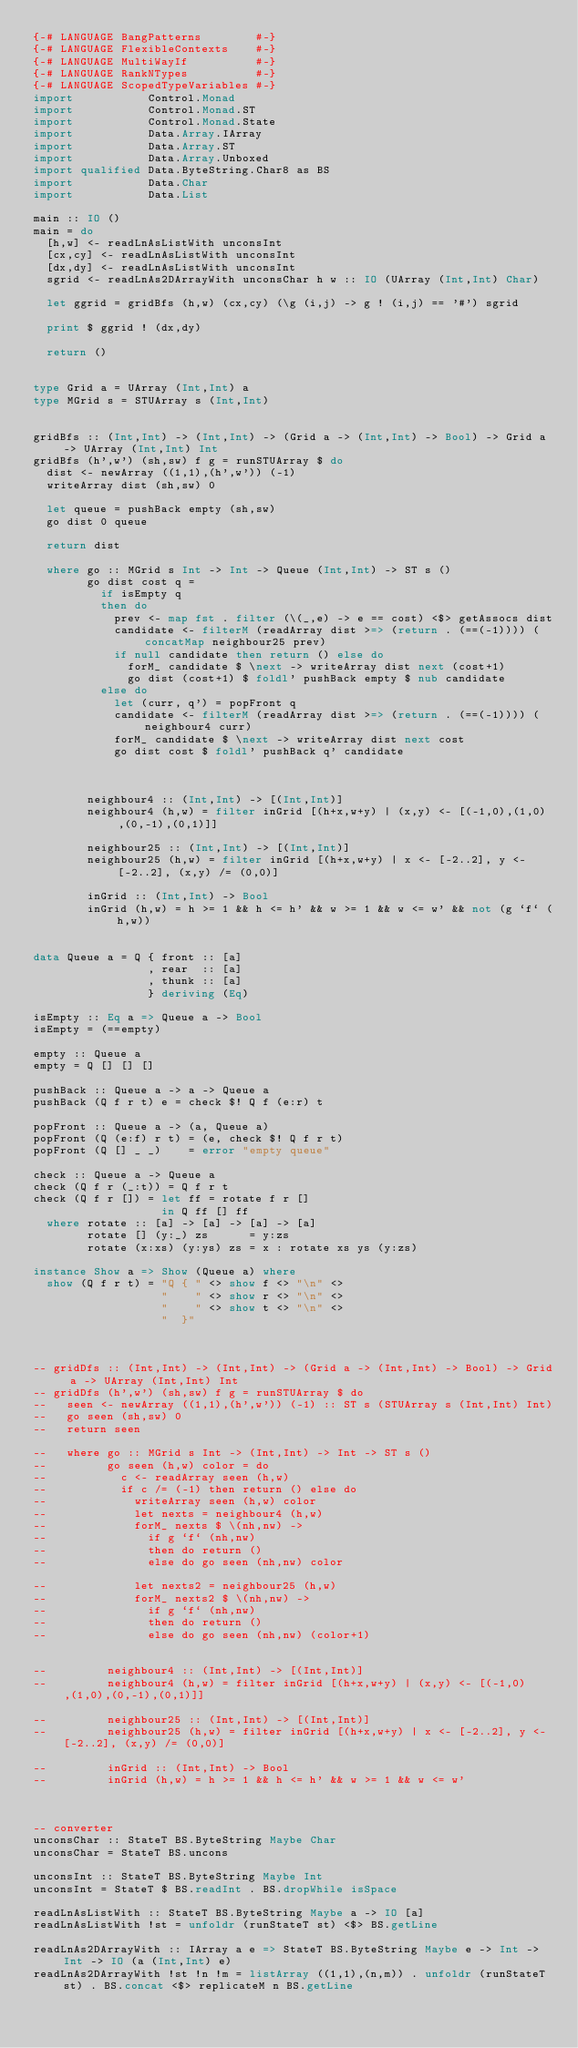<code> <loc_0><loc_0><loc_500><loc_500><_Haskell_>{-# LANGUAGE BangPatterns        #-}
{-# LANGUAGE FlexibleContexts    #-}
{-# LANGUAGE MultiWayIf          #-}
{-# LANGUAGE RankNTypes          #-}
{-# LANGUAGE ScopedTypeVariables #-}
import           Control.Monad
import           Control.Monad.ST
import           Control.Monad.State
import           Data.Array.IArray
import           Data.Array.ST
import           Data.Array.Unboxed
import qualified Data.ByteString.Char8 as BS
import           Data.Char
import           Data.List

main :: IO ()
main = do
  [h,w] <- readLnAsListWith unconsInt
  [cx,cy] <- readLnAsListWith unconsInt
  [dx,dy] <- readLnAsListWith unconsInt
  sgrid <- readLnAs2DArrayWith unconsChar h w :: IO (UArray (Int,Int) Char)

  let ggrid = gridBfs (h,w) (cx,cy) (\g (i,j) -> g ! (i,j) == '#') sgrid

  print $ ggrid ! (dx,dy)

  return ()


type Grid a = UArray (Int,Int) a
type MGrid s = STUArray s (Int,Int)


gridBfs :: (Int,Int) -> (Int,Int) -> (Grid a -> (Int,Int) -> Bool) -> Grid a -> UArray (Int,Int) Int
gridBfs (h',w') (sh,sw) f g = runSTUArray $ do
  dist <- newArray ((1,1),(h',w')) (-1)
  writeArray dist (sh,sw) 0

  let queue = pushBack empty (sh,sw)
  go dist 0 queue

  return dist

  where go :: MGrid s Int -> Int -> Queue (Int,Int) -> ST s ()
        go dist cost q =
          if isEmpty q
          then do
            prev <- map fst . filter (\(_,e) -> e == cost) <$> getAssocs dist
            candidate <- filterM (readArray dist >=> (return . (==(-1)))) (concatMap neighbour25 prev)
            if null candidate then return () else do
              forM_ candidate $ \next -> writeArray dist next (cost+1)
              go dist (cost+1) $ foldl' pushBack empty $ nub candidate
          else do
            let (curr, q') = popFront q
            candidate <- filterM (readArray dist >=> (return . (==(-1)))) (neighbour4 curr)
            forM_ candidate $ \next -> writeArray dist next cost
            go dist cost $ foldl' pushBack q' candidate



        neighbour4 :: (Int,Int) -> [(Int,Int)]
        neighbour4 (h,w) = filter inGrid [(h+x,w+y) | (x,y) <- [(-1,0),(1,0),(0,-1),(0,1)]]

        neighbour25 :: (Int,Int) -> [(Int,Int)]
        neighbour25 (h,w) = filter inGrid [(h+x,w+y) | x <- [-2..2], y <- [-2..2], (x,y) /= (0,0)]

        inGrid :: (Int,Int) -> Bool
        inGrid (h,w) = h >= 1 && h <= h' && w >= 1 && w <= w' && not (g `f` (h,w))


data Queue a = Q { front :: [a]
                 , rear  :: [a]
                 , thunk :: [a]
                 } deriving (Eq)

isEmpty :: Eq a => Queue a -> Bool
isEmpty = (==empty)

empty :: Queue a
empty = Q [] [] []

pushBack :: Queue a -> a -> Queue a
pushBack (Q f r t) e = check $! Q f (e:r) t

popFront :: Queue a -> (a, Queue a)
popFront (Q (e:f) r t) = (e, check $! Q f r t)
popFront (Q [] _ _)    = error "empty queue"

check :: Queue a -> Queue a
check (Q f r (_:t)) = Q f r t
check (Q f r []) = let ff = rotate f r []
                   in Q ff [] ff
  where rotate :: [a] -> [a] -> [a] -> [a]
        rotate [] (y:_) zs      = y:zs
        rotate (x:xs) (y:ys) zs = x : rotate xs ys (y:zs)

instance Show a => Show (Queue a) where
  show (Q f r t) = "Q { " <> show f <> "\n" <>
                   "    " <> show r <> "\n" <>
                   "    " <> show t <> "\n" <>
                   "  }"



-- gridDfs :: (Int,Int) -> (Int,Int) -> (Grid a -> (Int,Int) -> Bool) -> Grid a -> UArray (Int,Int) Int
-- gridDfs (h',w') (sh,sw) f g = runSTUArray $ do
--   seen <- newArray ((1,1),(h',w')) (-1) :: ST s (STUArray s (Int,Int) Int)
--   go seen (sh,sw) 0
--   return seen

--   where go :: MGrid s Int -> (Int,Int) -> Int -> ST s ()
--         go seen (h,w) color = do
--           c <- readArray seen (h,w)
--           if c /= (-1) then return () else do
--             writeArray seen (h,w) color
--             let nexts = neighbour4 (h,w)
--             forM_ nexts $ \(nh,nw) ->
--               if g `f` (nh,nw)
--               then do return ()
--               else do go seen (nh,nw) color

--             let nexts2 = neighbour25 (h,w)
--             forM_ nexts2 $ \(nh,nw) ->
--               if g `f` (nh,nw)
--               then do return ()
--               else do go seen (nh,nw) (color+1)


--         neighbour4 :: (Int,Int) -> [(Int,Int)]
--         neighbour4 (h,w) = filter inGrid [(h+x,w+y) | (x,y) <- [(-1,0),(1,0),(0,-1),(0,1)]]

--         neighbour25 :: (Int,Int) -> [(Int,Int)]
--         neighbour25 (h,w) = filter inGrid [(h+x,w+y) | x <- [-2..2], y <- [-2..2], (x,y) /= (0,0)]

--         inGrid :: (Int,Int) -> Bool
--         inGrid (h,w) = h >= 1 && h <= h' && w >= 1 && w <= w'



-- converter
unconsChar :: StateT BS.ByteString Maybe Char
unconsChar = StateT BS.uncons

unconsInt :: StateT BS.ByteString Maybe Int
unconsInt = StateT $ BS.readInt . BS.dropWhile isSpace

readLnAsListWith :: StateT BS.ByteString Maybe a -> IO [a]
readLnAsListWith !st = unfoldr (runStateT st) <$> BS.getLine

readLnAs2DArrayWith :: IArray a e => StateT BS.ByteString Maybe e -> Int -> Int -> IO (a (Int,Int) e)
readLnAs2DArrayWith !st !n !m = listArray ((1,1),(n,m)) . unfoldr (runStateT st) . BS.concat <$> replicateM n BS.getLine
</code> 